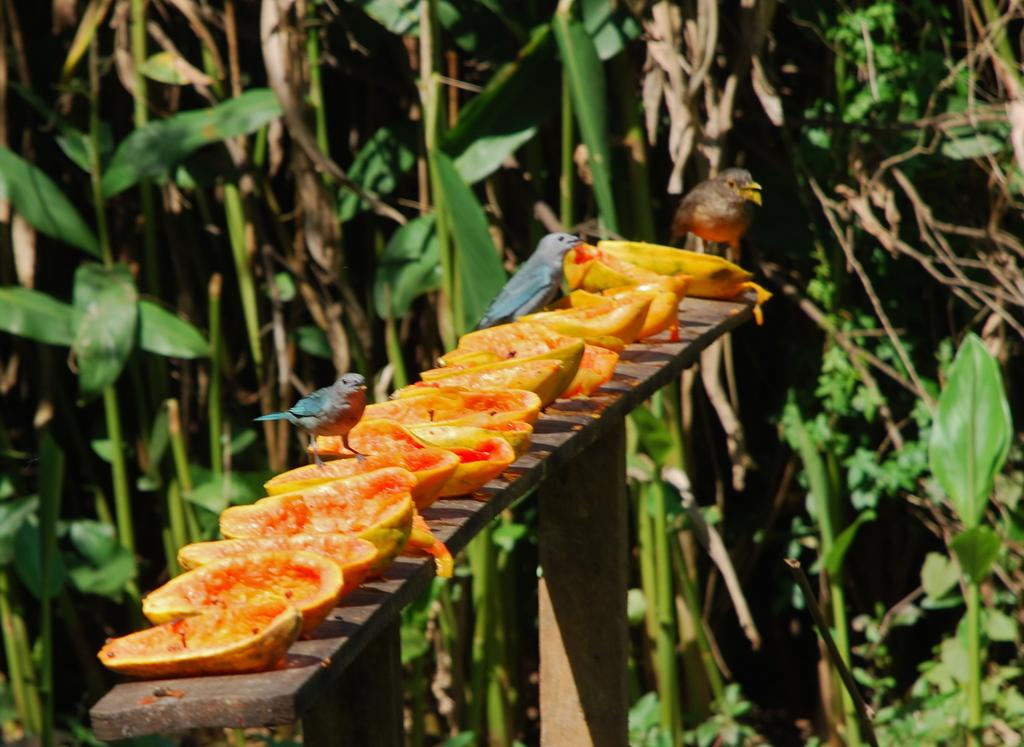What is the main structure in the image? There is a wooden stand in the image. What is placed on the wooden stand? Fruit pieces are on the wooden stand. What animals are interacting with the fruit pieces? Birds are standing on the fruit pieces. What type of vegetation can be seen in the background of the image? There are plants with leaves in the background of the image. What type of toys are the birds playing with in the image? There are no toys present in the image; the birds are standing on fruit pieces. 